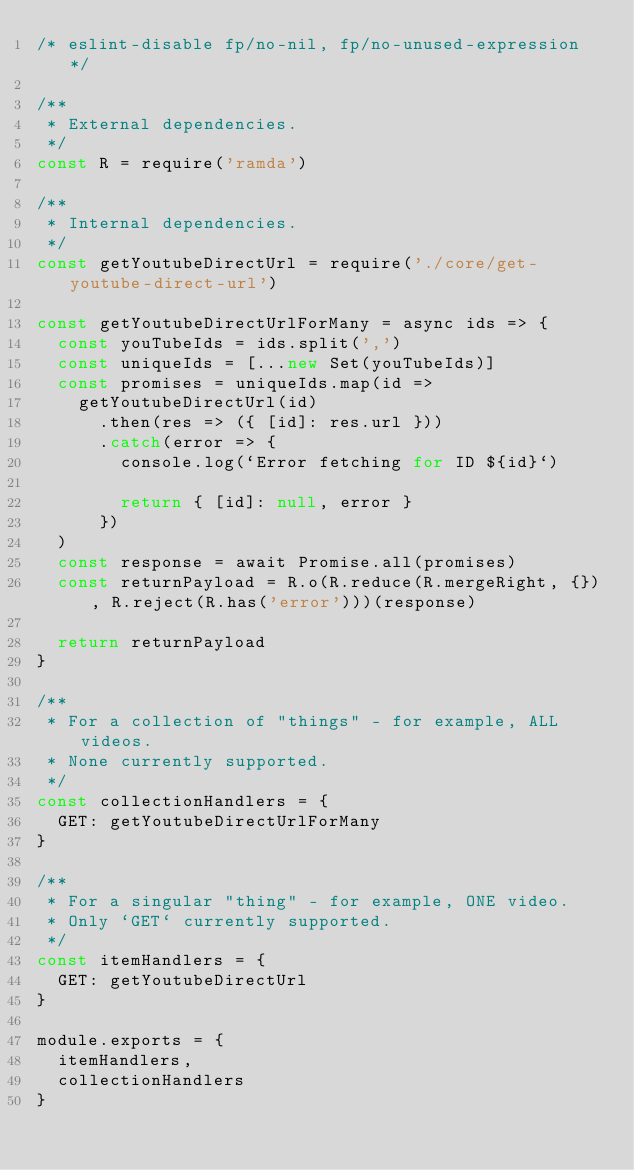Convert code to text. <code><loc_0><loc_0><loc_500><loc_500><_JavaScript_>/* eslint-disable fp/no-nil, fp/no-unused-expression */

/**
 * External dependencies.
 */
const R = require('ramda')

/**
 * Internal dependencies.
 */
const getYoutubeDirectUrl = require('./core/get-youtube-direct-url')

const getYoutubeDirectUrlForMany = async ids => {
  const youTubeIds = ids.split(',')
  const uniqueIds = [...new Set(youTubeIds)]
  const promises = uniqueIds.map(id =>
    getYoutubeDirectUrl(id)
      .then(res => ({ [id]: res.url }))
      .catch(error => {
        console.log(`Error fetching for ID ${id}`)

        return { [id]: null, error }
      })
  )
  const response = await Promise.all(promises)
  const returnPayload = R.o(R.reduce(R.mergeRight, {}), R.reject(R.has('error')))(response)

  return returnPayload
}

/**
 * For a collection of "things" - for example, ALL videos.
 * None currently supported.
 */
const collectionHandlers = {
  GET: getYoutubeDirectUrlForMany
}

/**
 * For a singular "thing" - for example, ONE video.
 * Only `GET` currently supported.
 */
const itemHandlers = {
  GET: getYoutubeDirectUrl
}

module.exports = {
  itemHandlers,
  collectionHandlers
}
</code> 